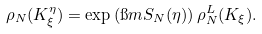Convert formula to latex. <formula><loc_0><loc_0><loc_500><loc_500>\rho _ { N } ( K ^ { \eta } _ { \xi } ) = \exp \left ( \i m S _ { N } ( \eta ) \right ) \rho _ { N } ^ { L } ( K _ { \xi } ) .</formula> 